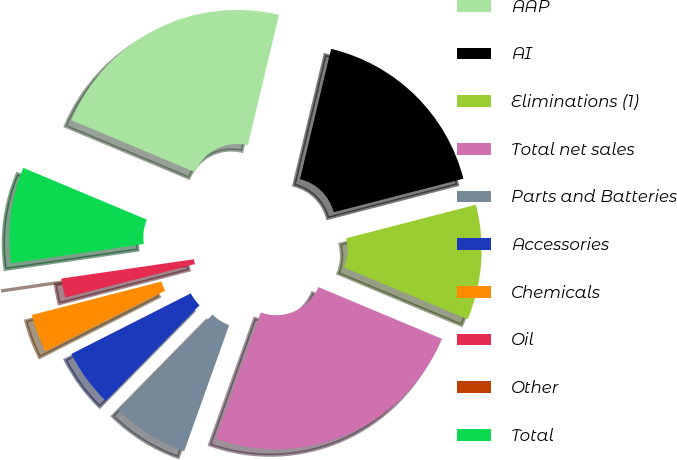Convert chart. <chart><loc_0><loc_0><loc_500><loc_500><pie_chart><fcel>AAP<fcel>AI<fcel>Eliminations (1)<fcel>Total net sales<fcel>Parts and Batteries<fcel>Accessories<fcel>Chemicals<fcel>Oil<fcel>Other<fcel>Total<nl><fcel>22.41%<fcel>17.24%<fcel>10.34%<fcel>24.14%<fcel>6.9%<fcel>5.17%<fcel>3.45%<fcel>1.72%<fcel>0.0%<fcel>8.62%<nl></chart> 